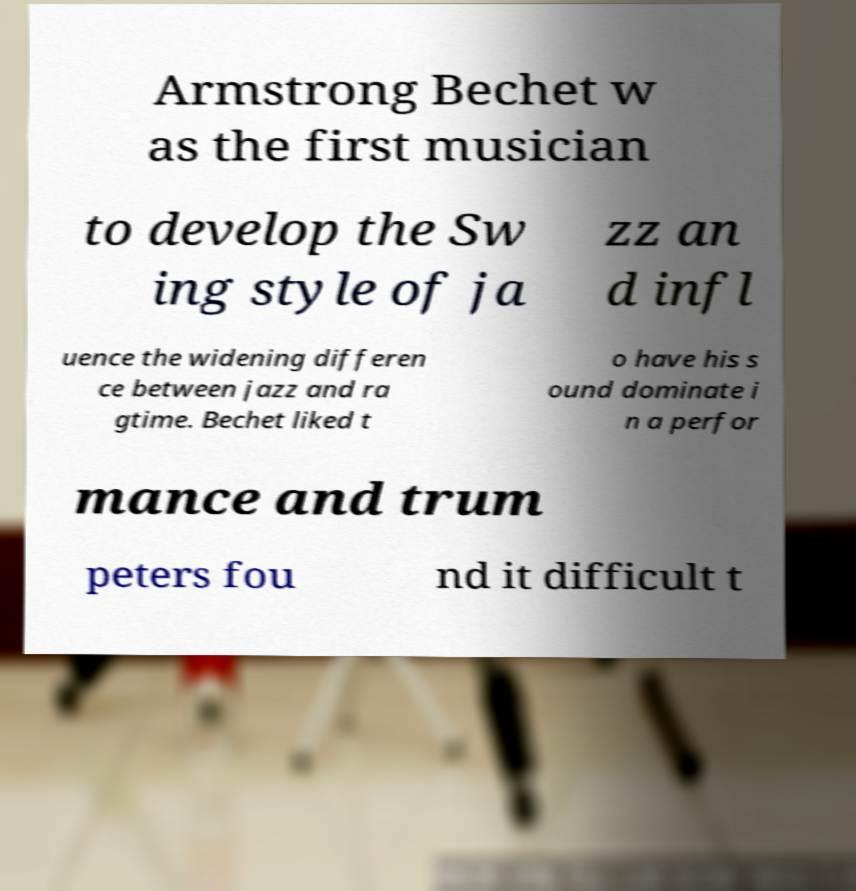What messages or text are displayed in this image? I need them in a readable, typed format. Armstrong Bechet w as the first musician to develop the Sw ing style of ja zz an d infl uence the widening differen ce between jazz and ra gtime. Bechet liked t o have his s ound dominate i n a perfor mance and trum peters fou nd it difficult t 